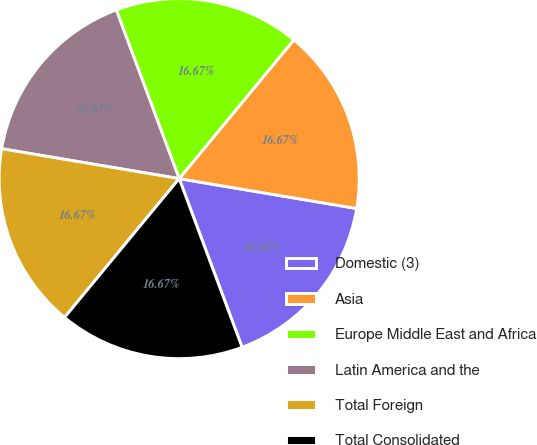Convert chart to OTSL. <chart><loc_0><loc_0><loc_500><loc_500><pie_chart><fcel>Domestic (3)<fcel>Asia<fcel>Europe Middle East and Africa<fcel>Latin America and the<fcel>Total Foreign<fcel>Total Consolidated<nl><fcel>16.66%<fcel>16.67%<fcel>16.67%<fcel>16.67%<fcel>16.67%<fcel>16.67%<nl></chart> 